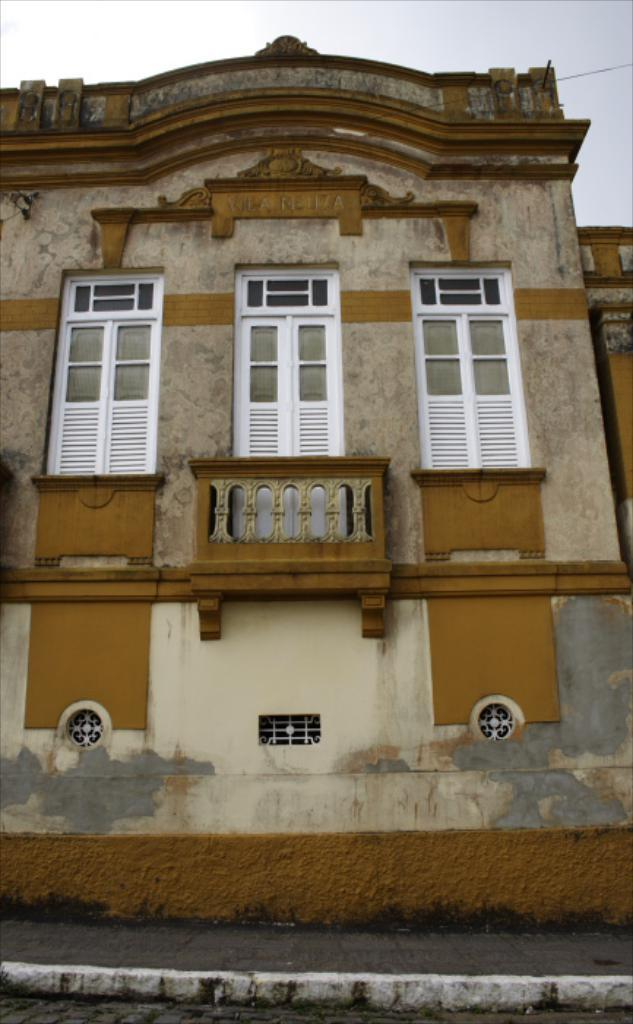What type of structure is present in the image? There is a building in the image. What can be observed about the windows of the building? The building has white-colored windows. What is located on the right side of the image? There is a wire on the right side of the image. We start by identifying the main subject in the image, which is the bowl of ice cream. Then, we expand the conversation to include other items that are also visible, such as sweets, plastic spoons, the mobile, and napkins. Each question is designed to elicit a specific detail about the image that is known from the provided facts. Absurd Question/Answer: How does the ice cream move around in the image? The ice cream does not move around in the image; it is in the bowl. --- Facts: 1. There is a building in the image. 2. The building has white-colored windows. 3. There is a wire on the right side of the image. 4. The sky is visible in the background of the image. Absurd Topics: rabbits, hand, lumber Conversation: What type of structure is present in the image? There is a building in the image. What can be observed about the windows of the building? The building has white-colored windows. What is located on the right side of the image? There is a wire on the right side of the image. What is visible in the background of the image? The sky is visible in the background of the image. How many rabbits are hopping around the building in the image? There are no rabbits present in the image; it features a building with white-colored windows and a wire on the right side. What type of lumber is being used to construct the building in the image? The image does not provide information about the materials used to construct the building. 